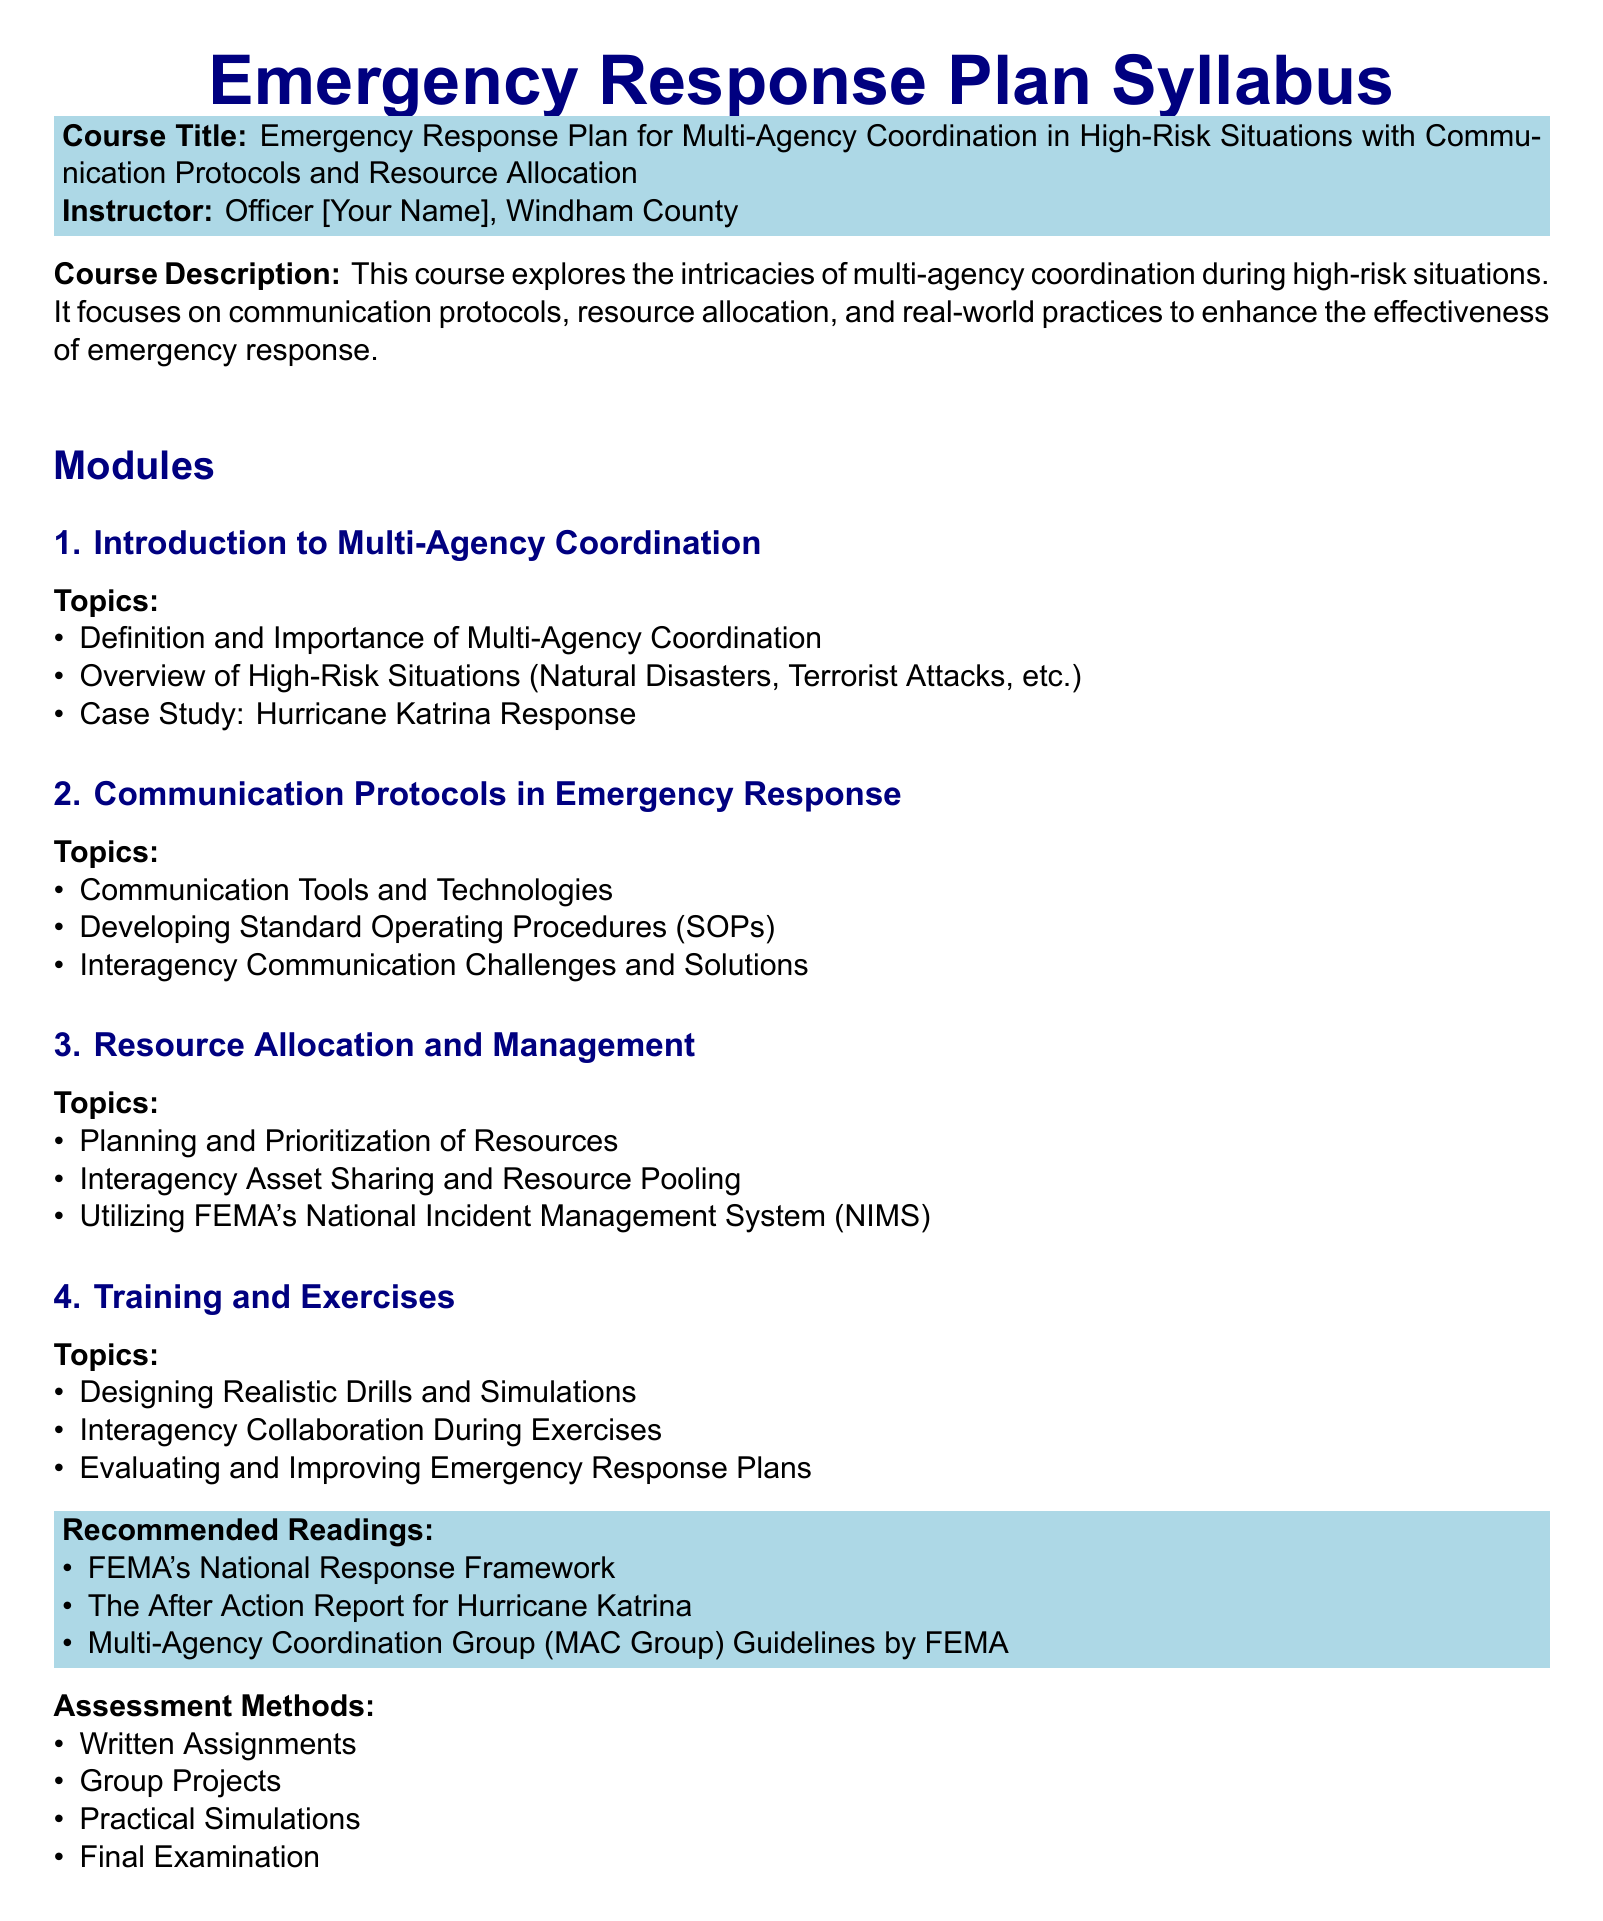What is the course title? The course title is mentioned at the beginning of the syllabus under the course description section.
Answer: Emergency Response Plan for Multi-Agency Coordination in High-Risk Situations with Communication Protocols and Resource Allocation Who is the instructor? The instructor's name is provided right after the course title in the syllabus.
Answer: Officer [Your Name], Windham County What is the first module about? The first module is listed under the "Modules" section and includes specific topics to be covered.
Answer: Introduction to Multi-Agency Coordination What case study is included in the syllabus? The case study is referenced in the first module, highlighting its relevance to the course content.
Answer: Hurricane Katrina Response Which document is recommended reading for this course? The recommended readings are listed in a specific section of the syllabus and include several key texts.
Answer: FEMA's National Response Framework How many assessment methods are mentioned? The assessment methods section lists multiple types of assessments for the course, which can be tallied.
Answer: Four What is one topic covered under "Resource Allocation and Management"? This topic can be found in the list of topics under the third module of the syllabus.
Answer: Interagency Asset Sharing and Resource Pooling What is the purpose of the training and exercises module? This module outlines specific activities to enhance coordination in high-risk situations.
Answer: Evaluating and Improving Emergency Response Plans Which system does the syllabus mention for utilizing FEMA resources? This information is noted within the resource management topics section.
Answer: National Incident Management System (NIMS) 